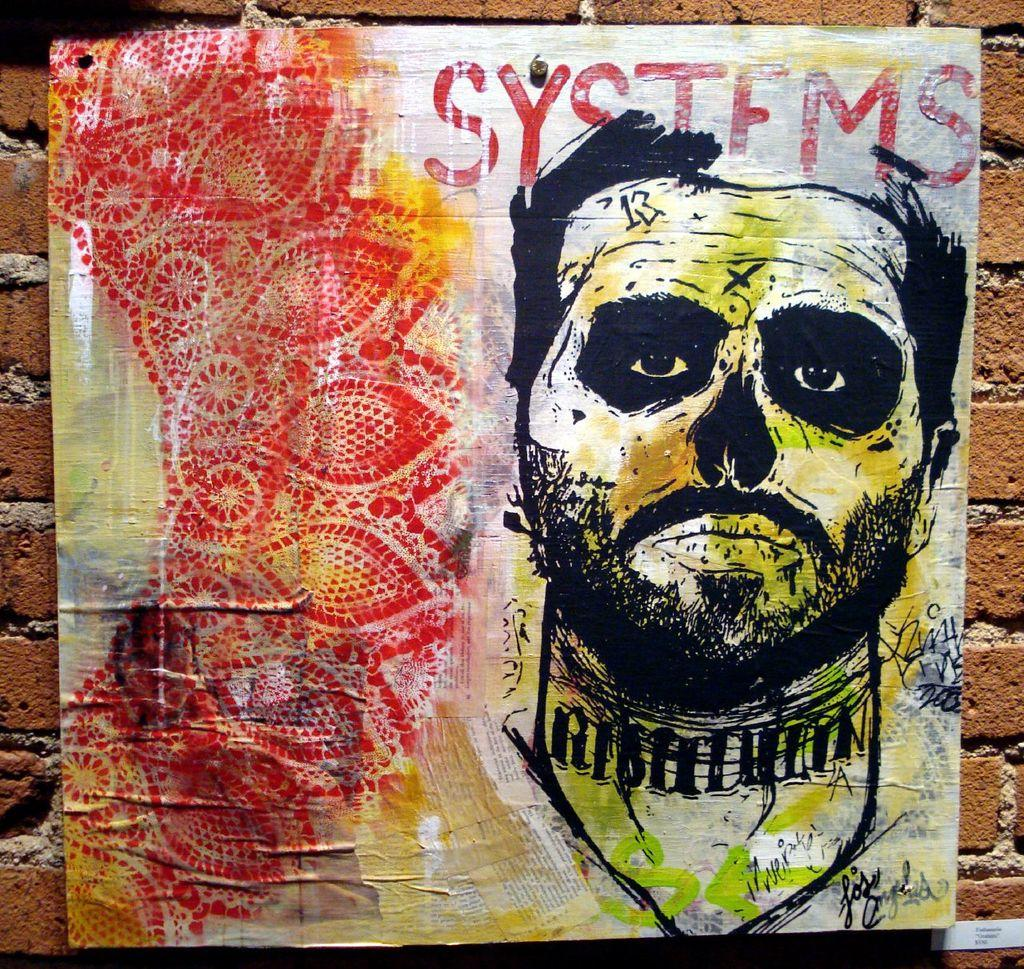What is the main object in the image? There is a board in the image. What is on the board? The board has a painting attached to it. Where is the board located? The board is attached to a brick wall. Can you see a kitty playing with a potato near the guitar in the image? There is no kitty, potato, or guitar present in the image. 